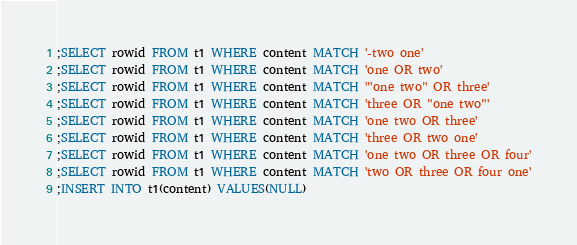<code> <loc_0><loc_0><loc_500><loc_500><_SQL_>;SELECT rowid FROM t1 WHERE content MATCH '-two one'
;SELECT rowid FROM t1 WHERE content MATCH 'one OR two'
;SELECT rowid FROM t1 WHERE content MATCH '"one two" OR three'
;SELECT rowid FROM t1 WHERE content MATCH 'three OR "one two"'
;SELECT rowid FROM t1 WHERE content MATCH 'one two OR three'
;SELECT rowid FROM t1 WHERE content MATCH 'three OR two one'
;SELECT rowid FROM t1 WHERE content MATCH 'one two OR three OR four'
;SELECT rowid FROM t1 WHERE content MATCH 'two OR three OR four one'
;INSERT INTO t1(content) VALUES(NULL)</code> 